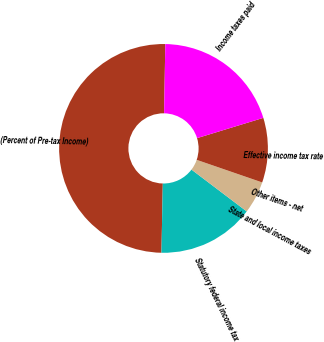<chart> <loc_0><loc_0><loc_500><loc_500><pie_chart><fcel>(Percent of Pre-tax Income)<fcel>Statutory federal income tax<fcel>State and local income taxes<fcel>Other items - net<fcel>Effective income tax rate<fcel>Income taxes paid<nl><fcel>49.96%<fcel>15.0%<fcel>5.01%<fcel>0.02%<fcel>10.01%<fcel>20.0%<nl></chart> 